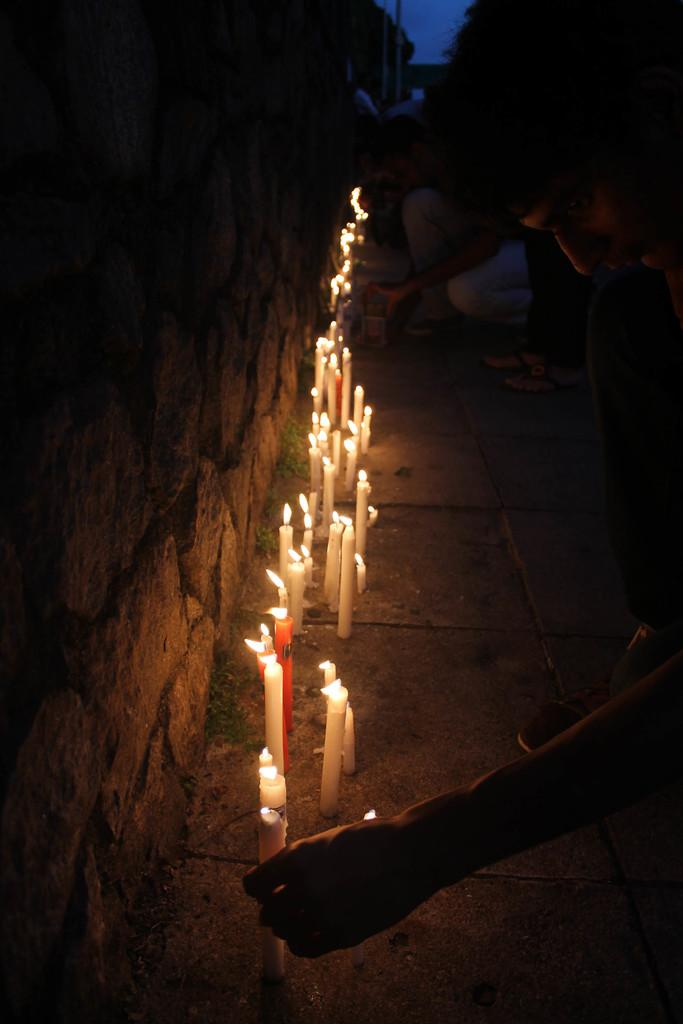What objects are on the ground in the image? There are candles on the ground in the image. What can be seen to the left of the image? There is a wall to the left of the image. What is present to the right of the image? There is a person to the right of the image. How would you describe the lighting in the image? The image is dark. What type of lipstick is the person wearing in the image? There is no indication of the person wearing lipstick or any makeup in the image. How does the person's digestion appear to be in the image? There is no information about the person's digestion in the image. 